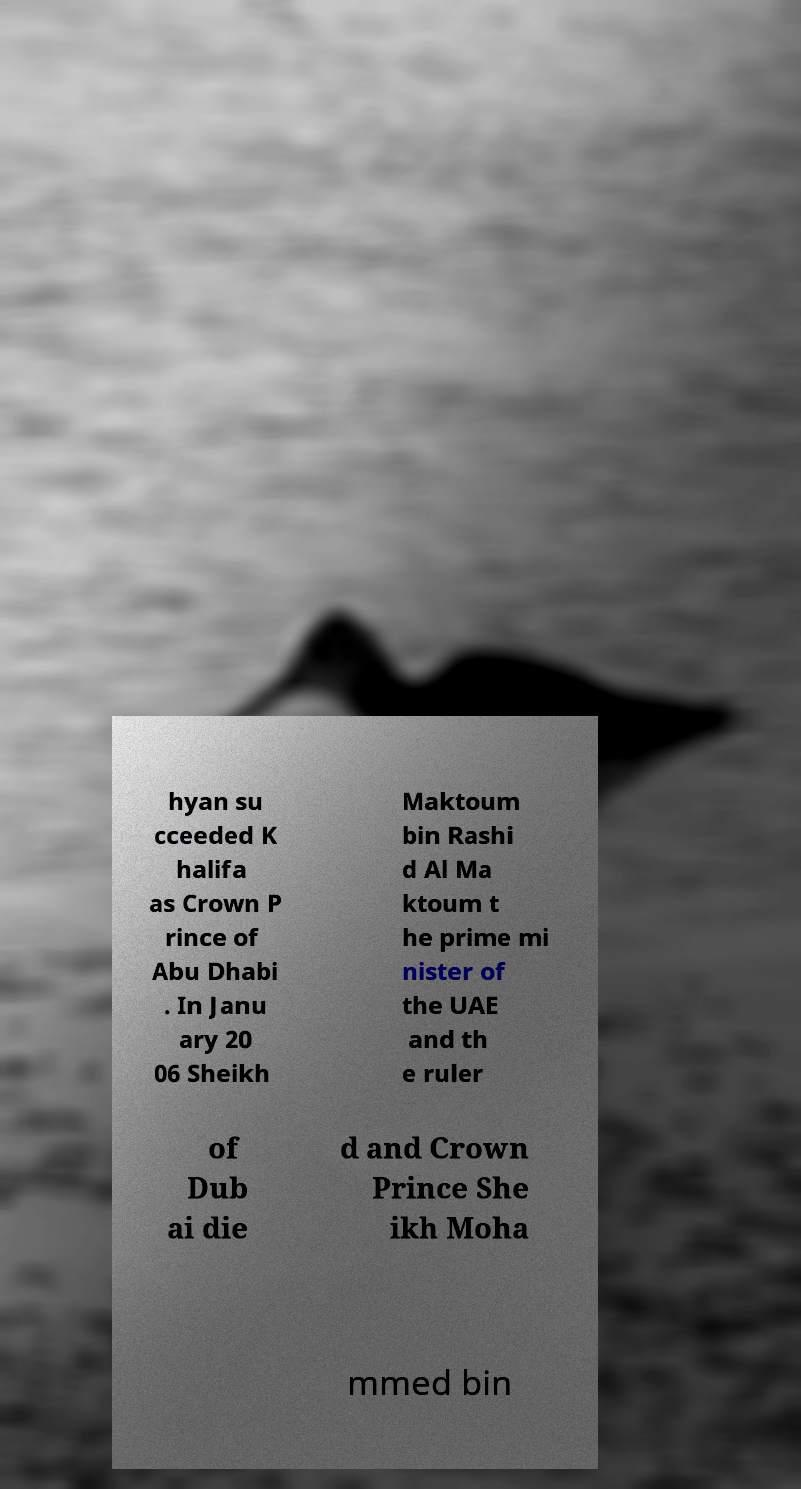What messages or text are displayed in this image? I need them in a readable, typed format. hyan su cceeded K halifa as Crown P rince of Abu Dhabi . In Janu ary 20 06 Sheikh Maktoum bin Rashi d Al Ma ktoum t he prime mi nister of the UAE and th e ruler of Dub ai die d and Crown Prince She ikh Moha mmed bin 